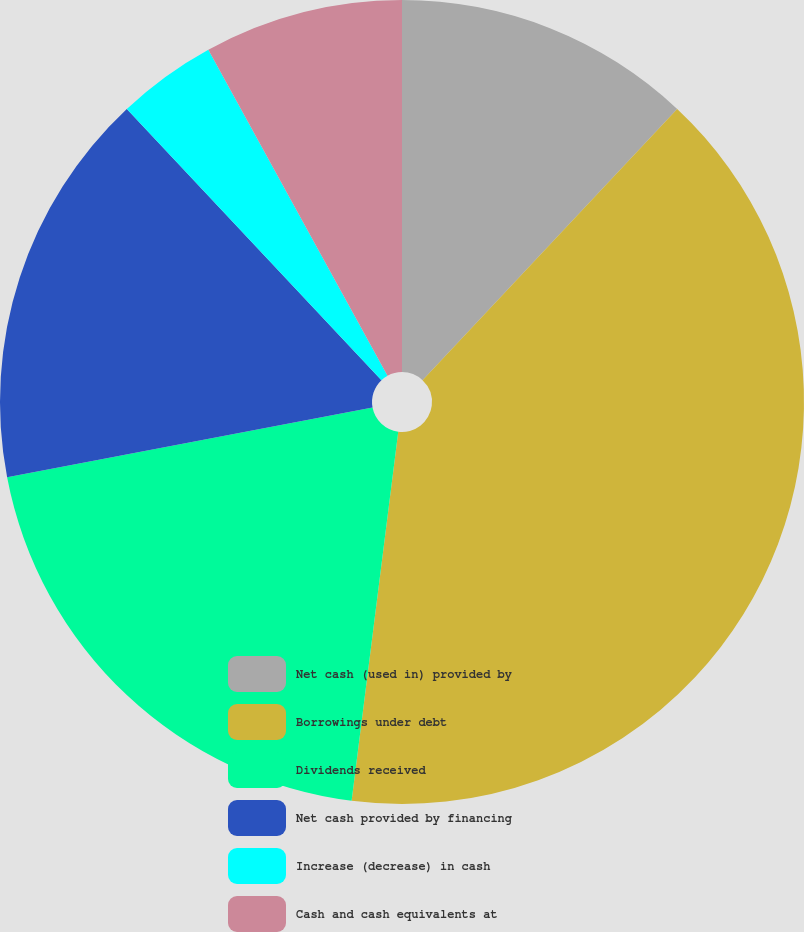Convert chart. <chart><loc_0><loc_0><loc_500><loc_500><pie_chart><fcel>Net cash (used in) provided by<fcel>Borrowings under debt<fcel>Dividends received<fcel>Net cash provided by financing<fcel>Increase (decrease) in cash<fcel>Cash and cash equivalents at<nl><fcel>12.0%<fcel>40.0%<fcel>20.0%<fcel>16.0%<fcel>4.0%<fcel>8.0%<nl></chart> 